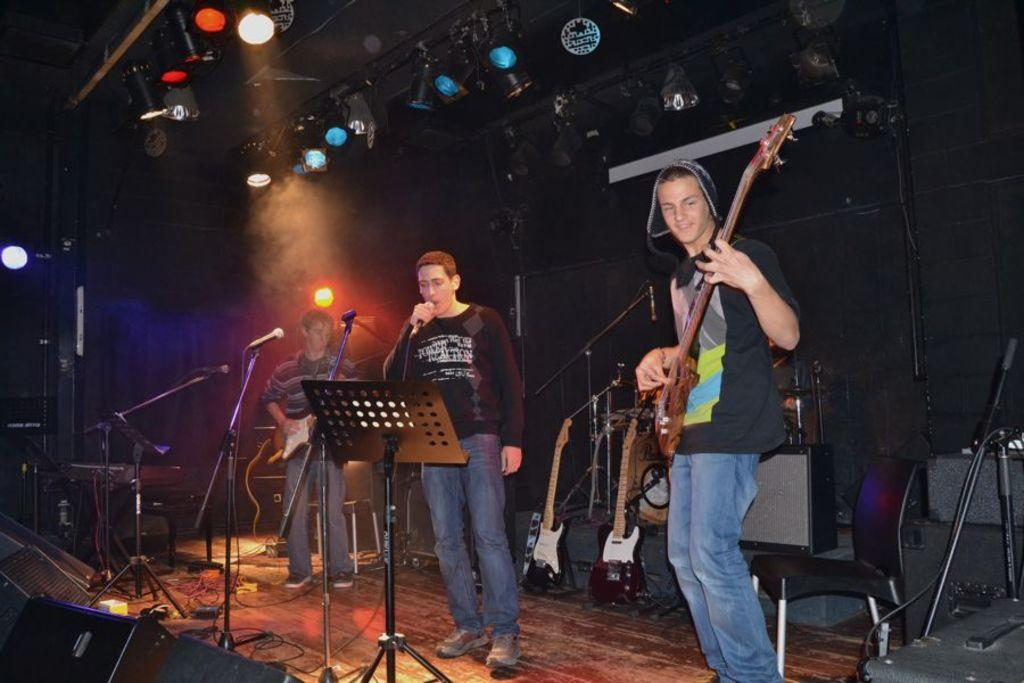What type of performance is taking place in the image? A rock band is performing on a stage. Where is the performance taking place? The band is performing at a concert. Who is the lead singer in the image? A man is singing with a microphone. Where is the lead singer positioned on the stage? The man is positioned in the center of the stage. What are the other band members doing in the image? Two other band members are playing guitars, one on each side of the singer. What type of gold jewelry is the lead singer wearing in the image? There is no mention of gold jewelry in the image; the focus is on the band's performance. Is there a ship visible in the background of the image? No, there is no ship present in the image. 